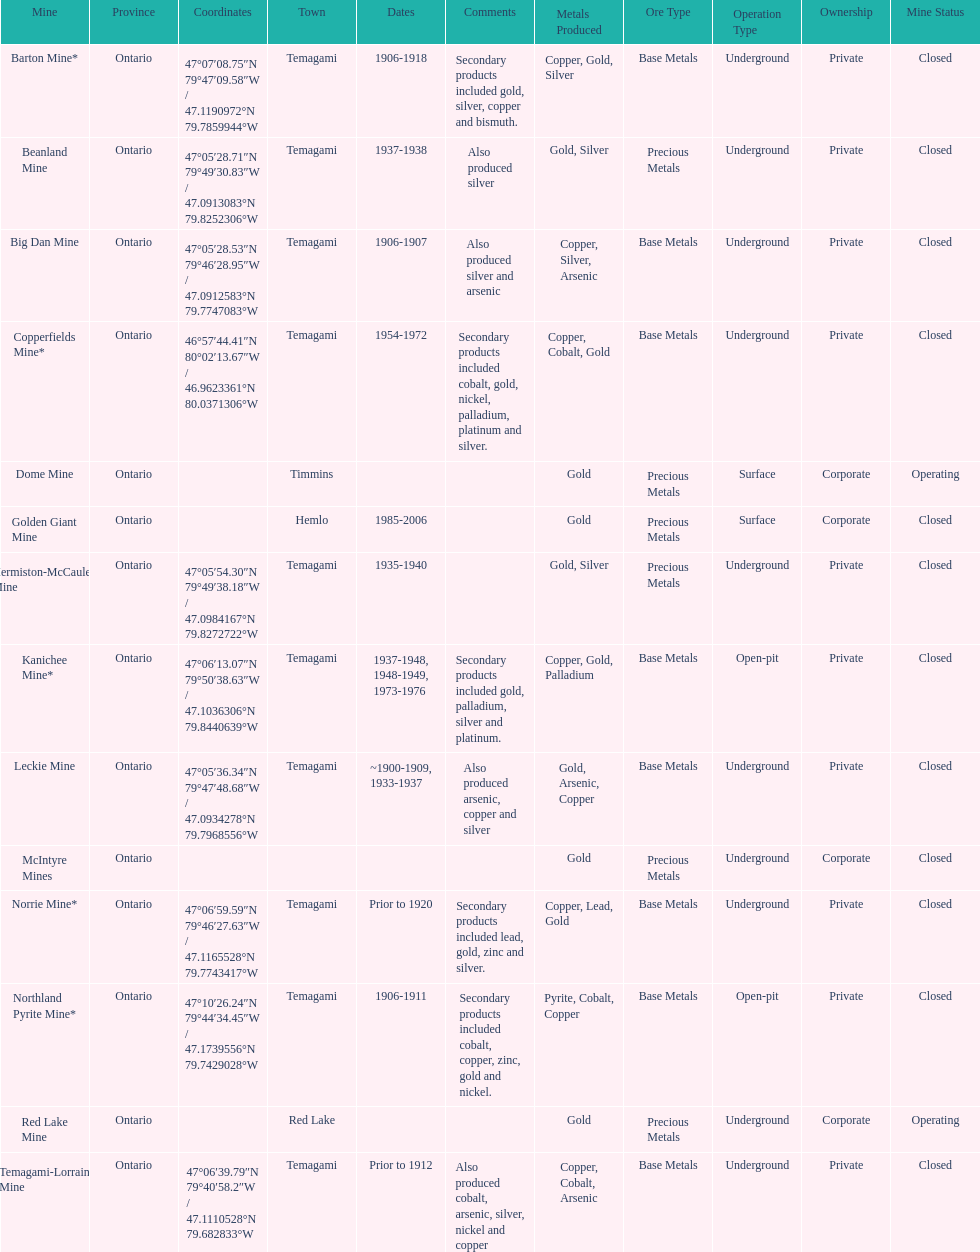In what mine could you find bismuth? Barton Mine. 